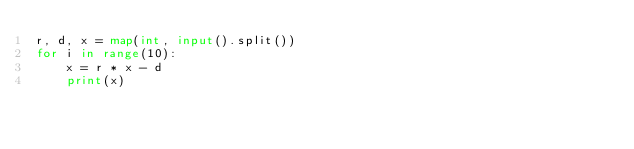Convert code to text. <code><loc_0><loc_0><loc_500><loc_500><_Python_>r, d, x = map(int, input().split())
for i in range(10):
    x = r * x - d
    print(x)
</code> 